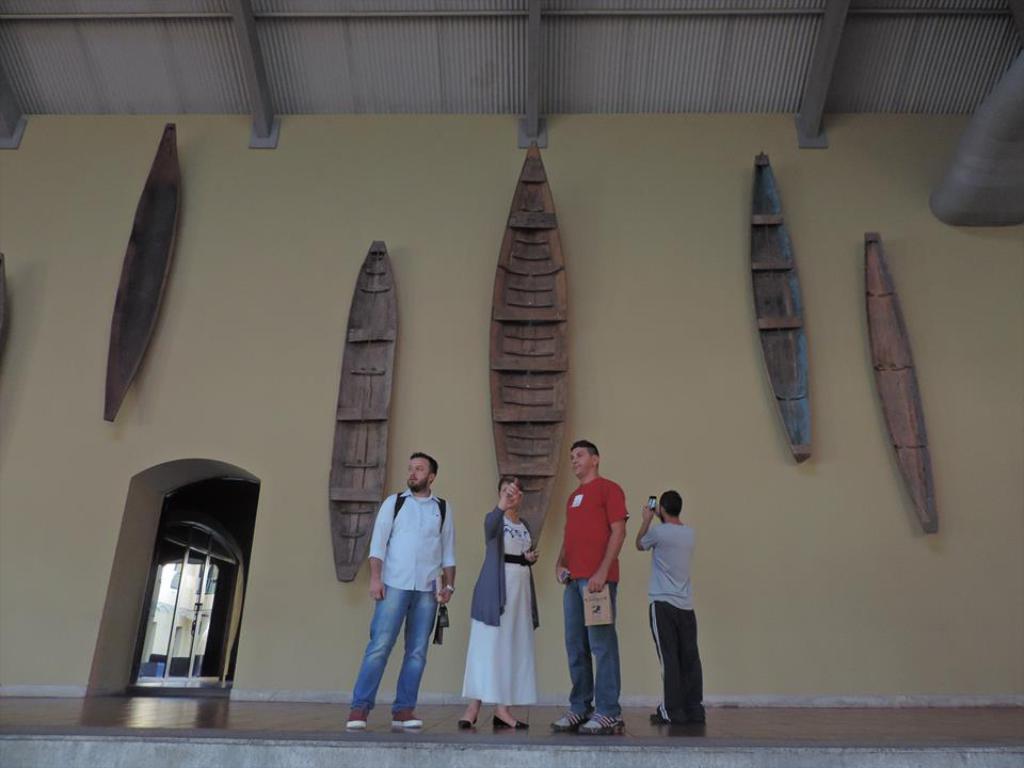Please provide a concise description of this image. In this image, we can see four persons are standing on the path and holding some objects. In the background, there are few boats on the wall. On the left side of the image, we can see the inside view of a house and a few objects. 